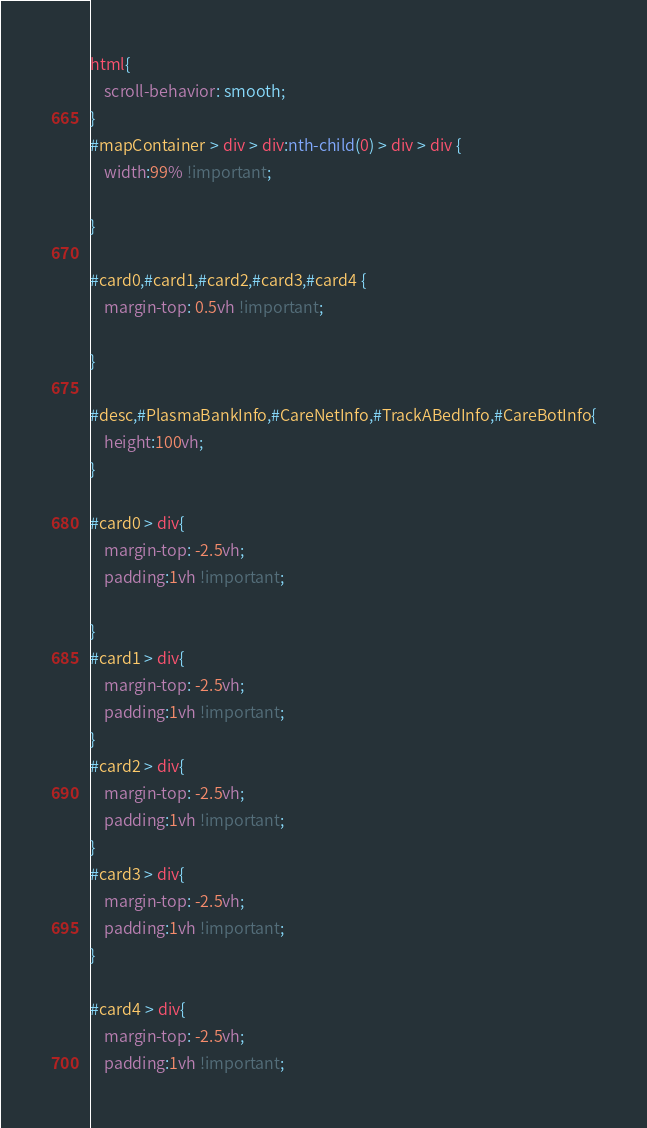Convert code to text. <code><loc_0><loc_0><loc_500><loc_500><_CSS_>html{
	scroll-behavior: smooth;
}
#mapContainer > div > div:nth-child(0) > div > div {
	width:99% !important;

}

#card0,#card1,#card2,#card3,#card4 {
	margin-top: 0.5vh !important;
	
}

#desc,#PlasmaBankInfo,#CareNetInfo,#TrackABedInfo,#CareBotInfo{
	height:100vh;
}

#card0 > div{
	margin-top: -2.5vh;
	padding:1vh !important;
	
}
#card1 > div{
	margin-top: -2.5vh;
	padding:1vh !important;
}
#card2 > div{
	margin-top: -2.5vh;
	padding:1vh !important;
}
#card3 > div{
	margin-top: -2.5vh;
	padding:1vh !important;
}

#card4 > div{
	margin-top: -2.5vh;
	padding:1vh !important;</code> 